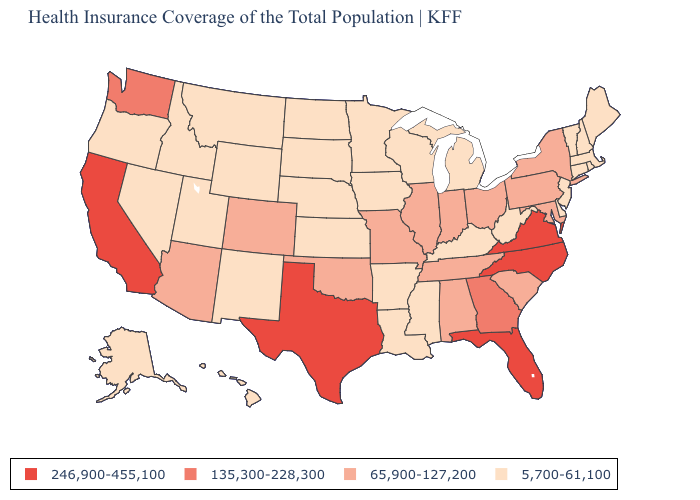Does New York have the highest value in the Northeast?
Be succinct. Yes. Which states hav the highest value in the West?
Short answer required. California. Is the legend a continuous bar?
Concise answer only. No. Name the states that have a value in the range 65,900-127,200?
Concise answer only. Alabama, Arizona, Colorado, Illinois, Indiana, Maryland, Missouri, New York, Ohio, Oklahoma, Pennsylvania, South Carolina, Tennessee. Name the states that have a value in the range 246,900-455,100?
Keep it brief. California, Florida, North Carolina, Texas, Virginia. Does Montana have the same value as Missouri?
Keep it brief. No. Which states have the lowest value in the USA?
Be succinct. Alaska, Arkansas, Connecticut, Delaware, Hawaii, Idaho, Iowa, Kansas, Kentucky, Louisiana, Maine, Massachusetts, Michigan, Minnesota, Mississippi, Montana, Nebraska, Nevada, New Hampshire, New Jersey, New Mexico, North Dakota, Oregon, Rhode Island, South Dakota, Utah, Vermont, West Virginia, Wisconsin, Wyoming. What is the highest value in states that border West Virginia?
Concise answer only. 246,900-455,100. What is the lowest value in states that border Michigan?
Write a very short answer. 5,700-61,100. What is the value of Wyoming?
Be succinct. 5,700-61,100. What is the value of North Dakota?
Quick response, please. 5,700-61,100. What is the lowest value in the USA?
Answer briefly. 5,700-61,100. Does the map have missing data?
Answer briefly. No. What is the lowest value in states that border Wyoming?
Concise answer only. 5,700-61,100. What is the value of Missouri?
Short answer required. 65,900-127,200. 